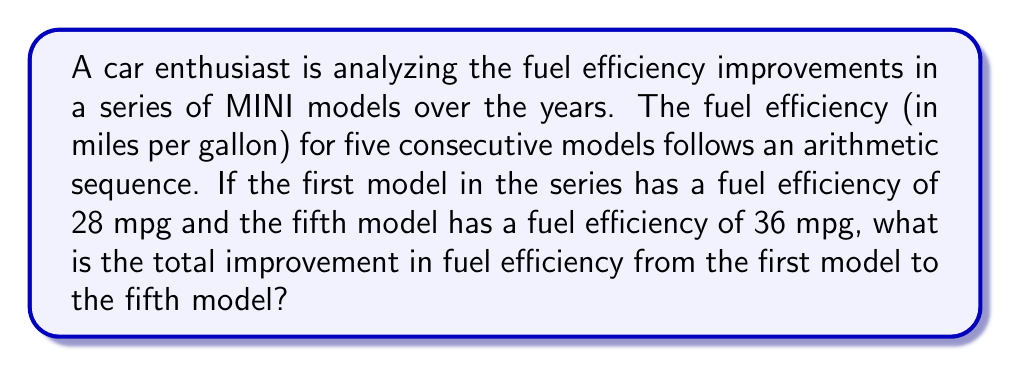What is the answer to this math problem? Let's approach this step-by-step:

1) In an arithmetic sequence, the difference between each term is constant. Let's call this common difference $d$.

2) We know the first term $a_1 = 28$ and the fifth term $a_5 = 36$.

3) In an arithmetic sequence, the nth term is given by:
   $a_n = a_1 + (n-1)d$

4) We can use this to set up an equation:
   $a_5 = a_1 + (5-1)d$
   $36 = 28 + 4d$

5) Solve for $d$:
   $8 = 4d$
   $d = 2$

6) So, the sequence is: 28, 30, 32, 34, 36

7) The total improvement is the difference between the last and first terms:
   $a_5 - a_1 = 36 - 28 = 8$

Therefore, the total improvement in fuel efficiency from the first model to the fifth model is 8 mpg.
Answer: 8 mpg 